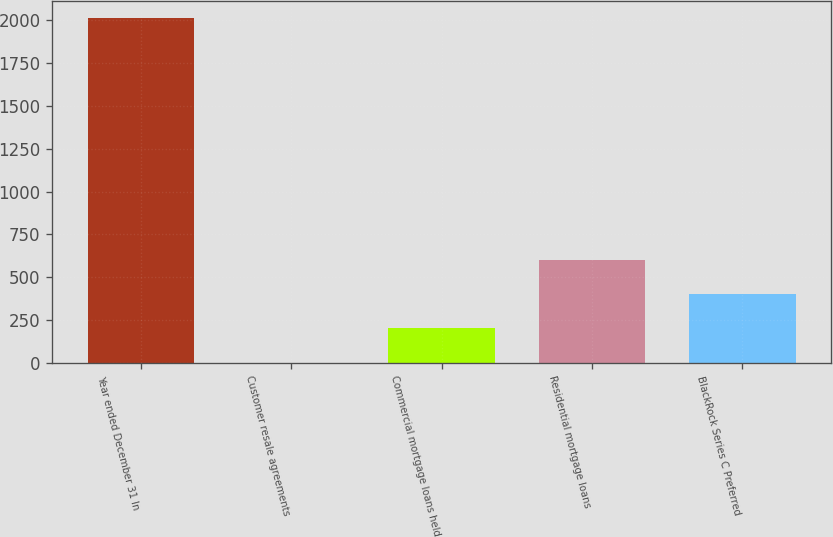Convert chart. <chart><loc_0><loc_0><loc_500><loc_500><bar_chart><fcel>Year ended December 31 In<fcel>Customer resale agreements<fcel>Commercial mortgage loans held<fcel>Residential mortgage loans<fcel>BlackRock Series C Preferred<nl><fcel>2010<fcel>1<fcel>201.9<fcel>603.7<fcel>402.8<nl></chart> 